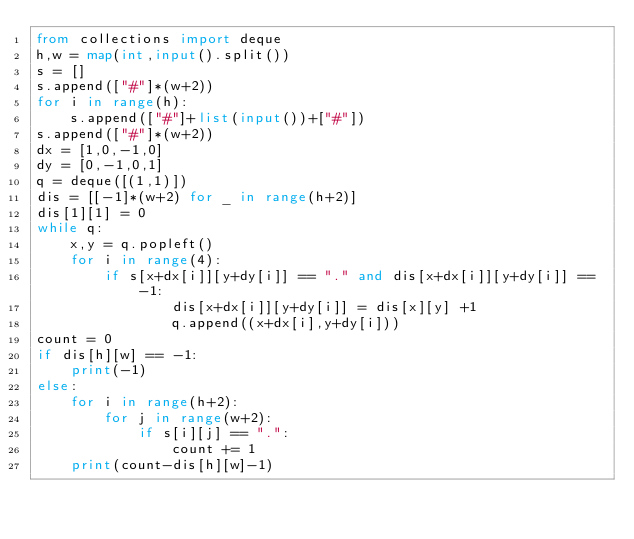Convert code to text. <code><loc_0><loc_0><loc_500><loc_500><_Python_>from collections import deque
h,w = map(int,input().split())
s = []
s.append(["#"]*(w+2))
for i in range(h):
    s.append(["#"]+list(input())+["#"])
s.append(["#"]*(w+2))
dx = [1,0,-1,0]
dy = [0,-1,0,1]
q = deque([(1,1)])
dis = [[-1]*(w+2) for _ in range(h+2)]
dis[1][1] = 0
while q:
    x,y = q.popleft()
    for i in range(4):
        if s[x+dx[i]][y+dy[i]] == "." and dis[x+dx[i]][y+dy[i]] == -1:
                dis[x+dx[i]][y+dy[i]] = dis[x][y] +1
                q.append((x+dx[i],y+dy[i]))
count = 0
if dis[h][w] == -1:
    print(-1)
else:
    for i in range(h+2):
        for j in range(w+2):
            if s[i][j] == ".":
                count += 1
    print(count-dis[h][w]-1)</code> 